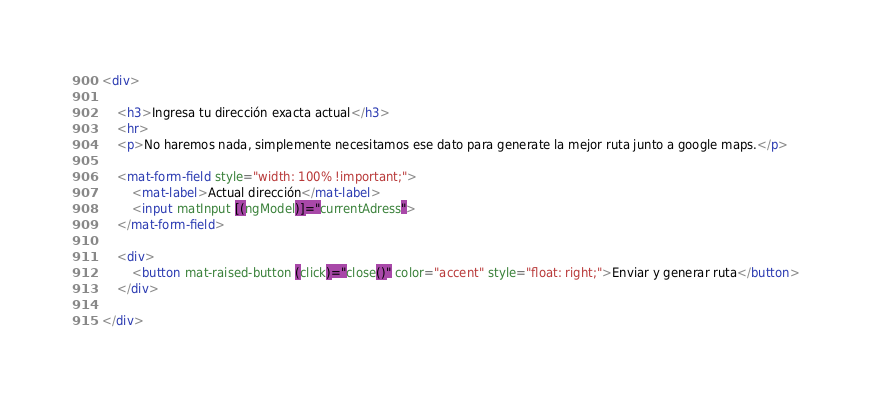<code> <loc_0><loc_0><loc_500><loc_500><_HTML_><div>

    <h3>Ingresa tu dirección exacta actual</h3>
    <hr>
    <p>No haremos nada, simplemente necesitamos ese dato para generate la mejor ruta junto a google maps.</p>

    <mat-form-field style="width: 100% !important;">
        <mat-label>Actual dirección</mat-label>
        <input matInput [(ngModel)]="currentAdress">
    </mat-form-field>

    <div>
        <button mat-raised-button (click)="close()" color="accent" style="float: right;">Enviar y generar ruta</button>
    </div>

</div></code> 